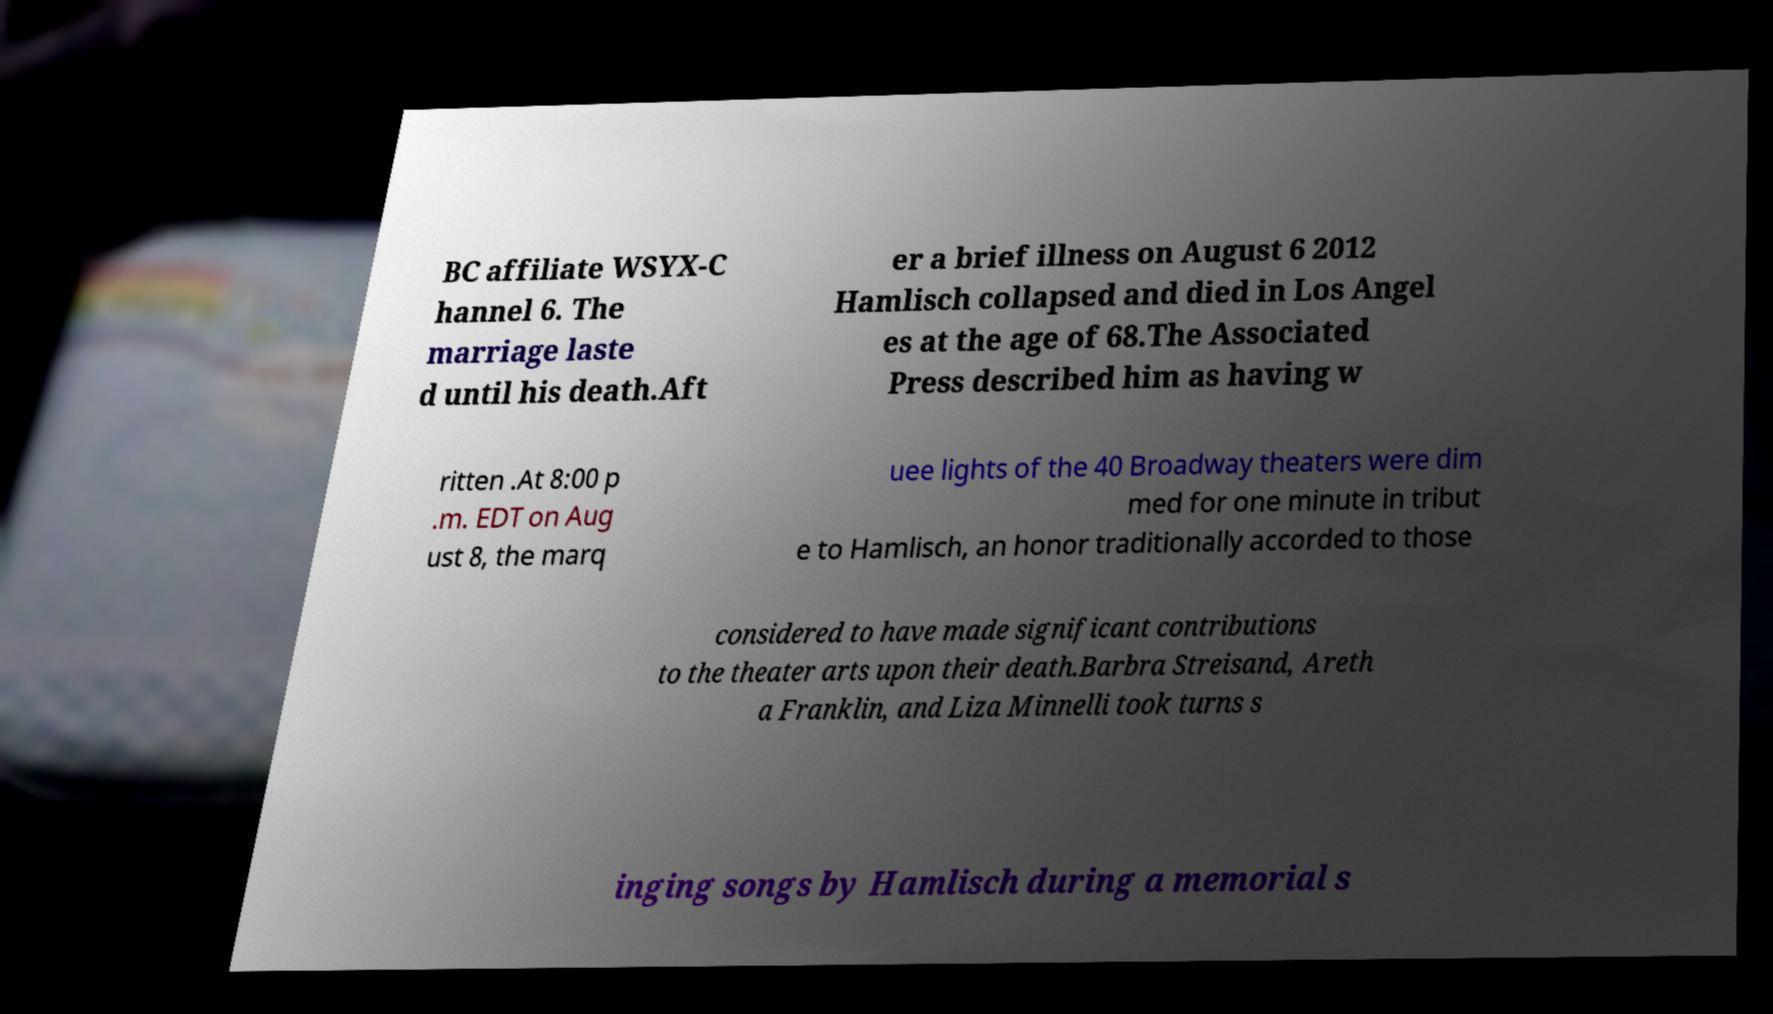For documentation purposes, I need the text within this image transcribed. Could you provide that? BC affiliate WSYX-C hannel 6. The marriage laste d until his death.Aft er a brief illness on August 6 2012 Hamlisch collapsed and died in Los Angel es at the age of 68.The Associated Press described him as having w ritten .At 8:00 p .m. EDT on Aug ust 8, the marq uee lights of the 40 Broadway theaters were dim med for one minute in tribut e to Hamlisch, an honor traditionally accorded to those considered to have made significant contributions to the theater arts upon their death.Barbra Streisand, Areth a Franklin, and Liza Minnelli took turns s inging songs by Hamlisch during a memorial s 